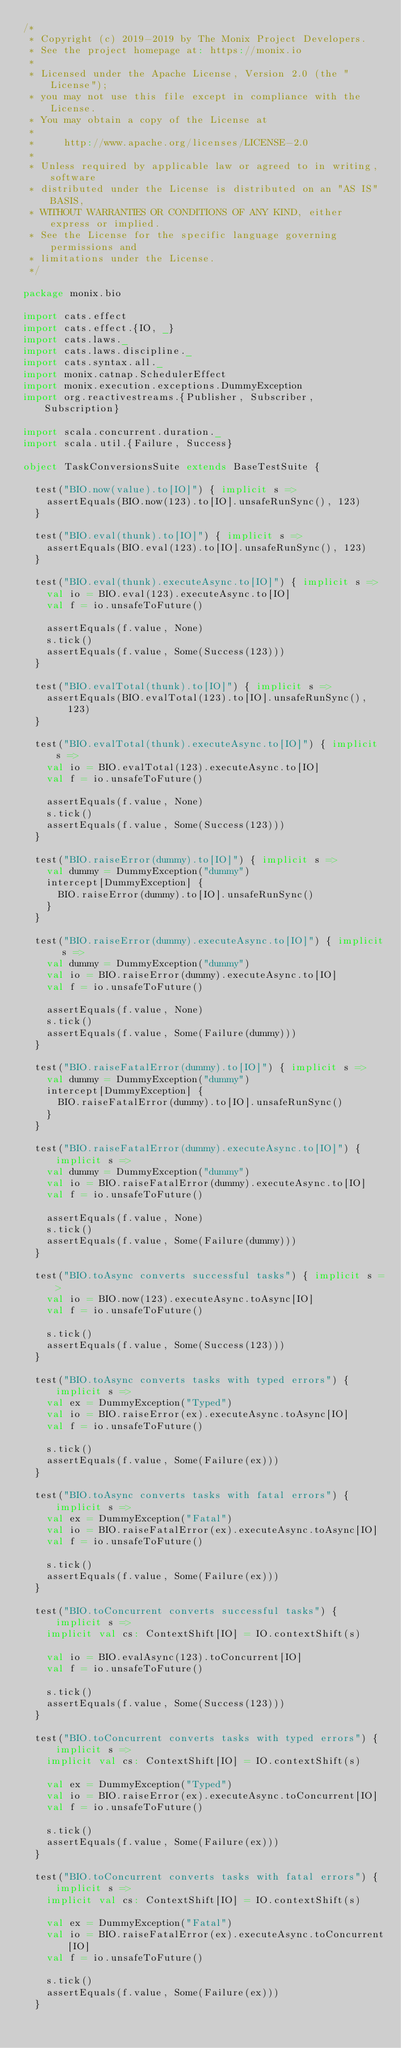<code> <loc_0><loc_0><loc_500><loc_500><_Scala_>/*
 * Copyright (c) 2019-2019 by The Monix Project Developers.
 * See the project homepage at: https://monix.io
 *
 * Licensed under the Apache License, Version 2.0 (the "License");
 * you may not use this file except in compliance with the License.
 * You may obtain a copy of the License at
 *
 *     http://www.apache.org/licenses/LICENSE-2.0
 *
 * Unless required by applicable law or agreed to in writing, software
 * distributed under the License is distributed on an "AS IS" BASIS,
 * WITHOUT WARRANTIES OR CONDITIONS OF ANY KIND, either express or implied.
 * See the License for the specific language governing permissions and
 * limitations under the License.
 */

package monix.bio

import cats.effect
import cats.effect.{IO, _}
import cats.laws._
import cats.laws.discipline._
import cats.syntax.all._
import monix.catnap.SchedulerEffect
import monix.execution.exceptions.DummyException
import org.reactivestreams.{Publisher, Subscriber, Subscription}

import scala.concurrent.duration._
import scala.util.{Failure, Success}

object TaskConversionsSuite extends BaseTestSuite {

  test("BIO.now(value).to[IO]") { implicit s =>
    assertEquals(BIO.now(123).to[IO].unsafeRunSync(), 123)
  }

  test("BIO.eval(thunk).to[IO]") { implicit s =>
    assertEquals(BIO.eval(123).to[IO].unsafeRunSync(), 123)
  }

  test("BIO.eval(thunk).executeAsync.to[IO]") { implicit s =>
    val io = BIO.eval(123).executeAsync.to[IO]
    val f = io.unsafeToFuture()

    assertEquals(f.value, None)
    s.tick()
    assertEquals(f.value, Some(Success(123)))
  }

  test("BIO.evalTotal(thunk).to[IO]") { implicit s =>
    assertEquals(BIO.evalTotal(123).to[IO].unsafeRunSync(), 123)
  }

  test("BIO.evalTotal(thunk).executeAsync.to[IO]") { implicit s =>
    val io = BIO.evalTotal(123).executeAsync.to[IO]
    val f = io.unsafeToFuture()

    assertEquals(f.value, None)
    s.tick()
    assertEquals(f.value, Some(Success(123)))
  }

  test("BIO.raiseError(dummy).to[IO]") { implicit s =>
    val dummy = DummyException("dummy")
    intercept[DummyException] {
      BIO.raiseError(dummy).to[IO].unsafeRunSync()
    }
  }

  test("BIO.raiseError(dummy).executeAsync.to[IO]") { implicit s =>
    val dummy = DummyException("dummy")
    val io = BIO.raiseError(dummy).executeAsync.to[IO]
    val f = io.unsafeToFuture()

    assertEquals(f.value, None)
    s.tick()
    assertEquals(f.value, Some(Failure(dummy)))
  }

  test("BIO.raiseFatalError(dummy).to[IO]") { implicit s =>
    val dummy = DummyException("dummy")
    intercept[DummyException] {
      BIO.raiseFatalError(dummy).to[IO].unsafeRunSync()
    }
  }

  test("BIO.raiseFatalError(dummy).executeAsync.to[IO]") { implicit s =>
    val dummy = DummyException("dummy")
    val io = BIO.raiseFatalError(dummy).executeAsync.to[IO]
    val f = io.unsafeToFuture()

    assertEquals(f.value, None)
    s.tick()
    assertEquals(f.value, Some(Failure(dummy)))
  }

  test("BIO.toAsync converts successful tasks") { implicit s =>
    val io = BIO.now(123).executeAsync.toAsync[IO]
    val f = io.unsafeToFuture()

    s.tick()
    assertEquals(f.value, Some(Success(123)))
  }

  test("BIO.toAsync converts tasks with typed errors") { implicit s =>
    val ex = DummyException("Typed")
    val io = BIO.raiseError(ex).executeAsync.toAsync[IO]
    val f = io.unsafeToFuture()

    s.tick()
    assertEquals(f.value, Some(Failure(ex)))
  }

  test("BIO.toAsync converts tasks with fatal errors") { implicit s =>
    val ex = DummyException("Fatal")
    val io = BIO.raiseFatalError(ex).executeAsync.toAsync[IO]
    val f = io.unsafeToFuture()

    s.tick()
    assertEquals(f.value, Some(Failure(ex)))
  }

  test("BIO.toConcurrent converts successful tasks") { implicit s =>
    implicit val cs: ContextShift[IO] = IO.contextShift(s)

    val io = BIO.evalAsync(123).toConcurrent[IO]
    val f = io.unsafeToFuture()

    s.tick()
    assertEquals(f.value, Some(Success(123)))
  }

  test("BIO.toConcurrent converts tasks with typed errors") { implicit s =>
    implicit val cs: ContextShift[IO] = IO.contextShift(s)

    val ex = DummyException("Typed")
    val io = BIO.raiseError(ex).executeAsync.toConcurrent[IO]
    val f = io.unsafeToFuture()

    s.tick()
    assertEquals(f.value, Some(Failure(ex)))
  }

  test("BIO.toConcurrent converts tasks with fatal errors") { implicit s =>
    implicit val cs: ContextShift[IO] = IO.contextShift(s)

    val ex = DummyException("Fatal")
    val io = BIO.raiseFatalError(ex).executeAsync.toConcurrent[IO]
    val f = io.unsafeToFuture()

    s.tick()
    assertEquals(f.value, Some(Failure(ex)))
  }
</code> 